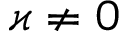Convert formula to latex. <formula><loc_0><loc_0><loc_500><loc_500>\varkappa \neq 0</formula> 